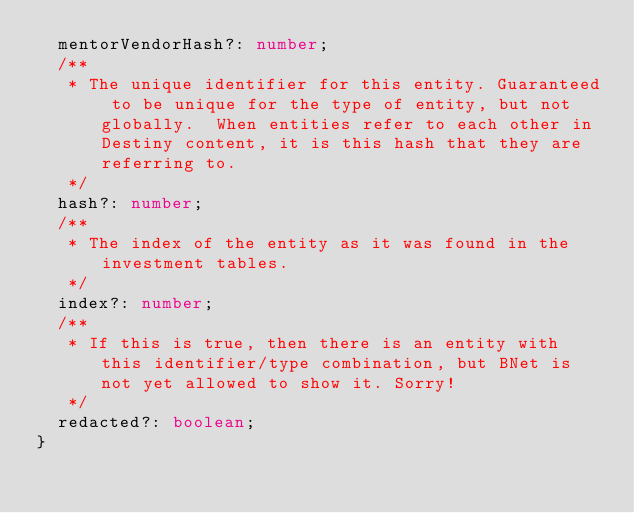<code> <loc_0><loc_0><loc_500><loc_500><_TypeScript_>  mentorVendorHash?: number;
  /**
   * The unique identifier for this entity. Guaranteed to be unique for the type of entity, but not globally.  When entities refer to each other in Destiny content, it is this hash that they are referring to.
   */
  hash?: number;
  /**
   * The index of the entity as it was found in the investment tables.
   */
  index?: number;
  /**
   * If this is true, then there is an entity with this identifier/type combination, but BNet is not yet allowed to show it. Sorry!
   */
  redacted?: boolean;
}
</code> 